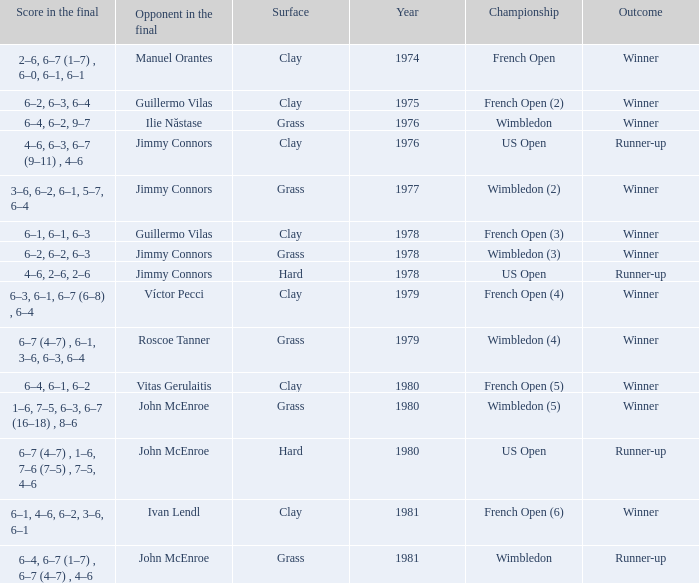What is every year where opponent in the final is John Mcenroe at Wimbledon? 1981.0. 